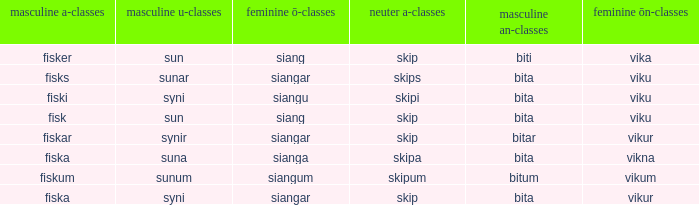What ending does siangu get for ön? Viku. 